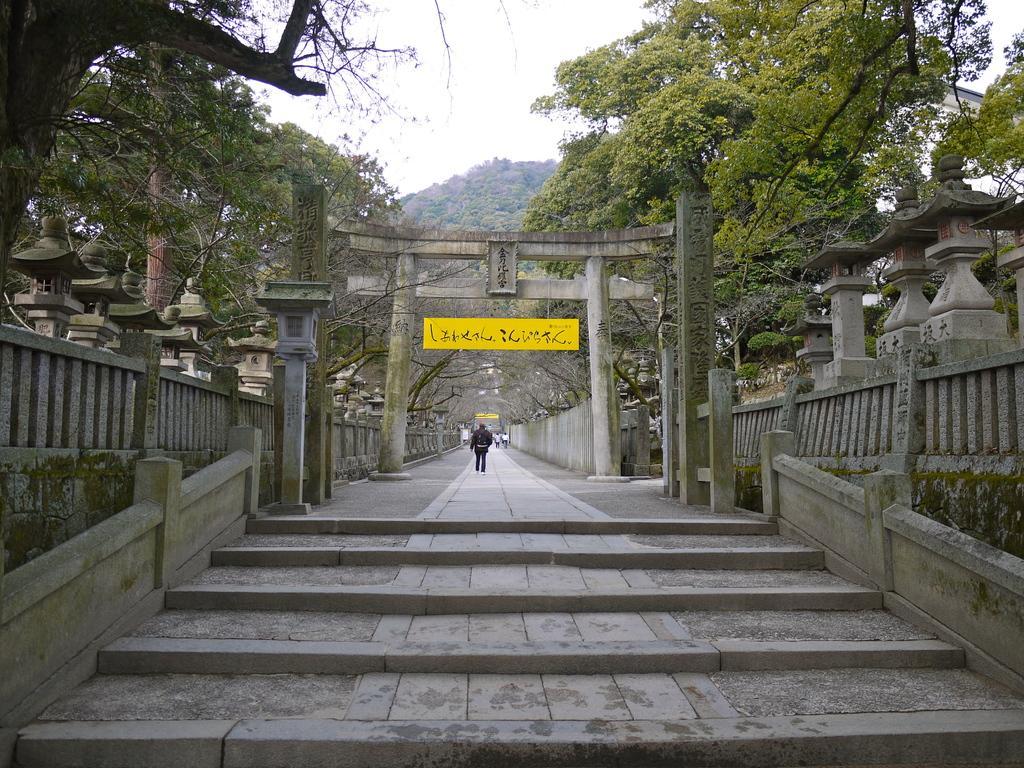Describe this image in one or two sentences. In this image we can see some people walking on the pathway under an arch. We can also see some stairs, a concrete grill, a board with some text on it, a group of trees, the bark of a tree and the sky which looks cloudy. 